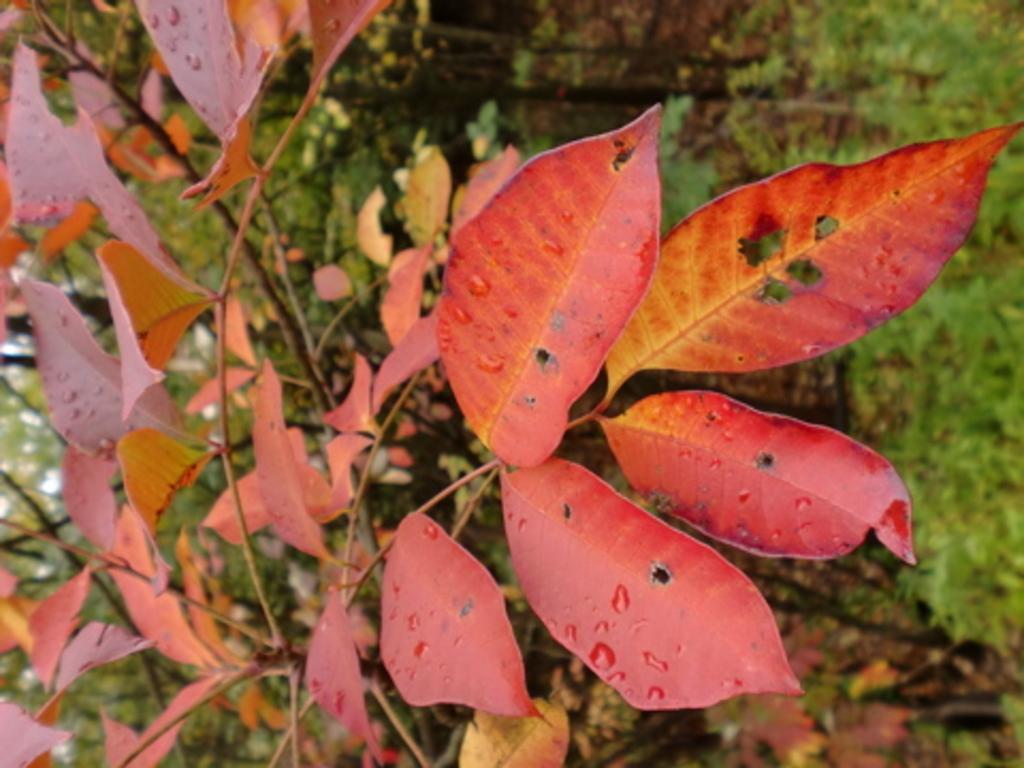In one or two sentences, can you explain what this image depicts? In this image we can see the dew on the orange color leaves. The background of the image is blurred, where we can see the grass. 